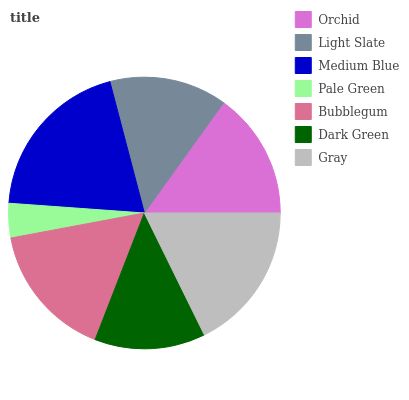Is Pale Green the minimum?
Answer yes or no. Yes. Is Medium Blue the maximum?
Answer yes or no. Yes. Is Light Slate the minimum?
Answer yes or no. No. Is Light Slate the maximum?
Answer yes or no. No. Is Orchid greater than Light Slate?
Answer yes or no. Yes. Is Light Slate less than Orchid?
Answer yes or no. Yes. Is Light Slate greater than Orchid?
Answer yes or no. No. Is Orchid less than Light Slate?
Answer yes or no. No. Is Orchid the high median?
Answer yes or no. Yes. Is Orchid the low median?
Answer yes or no. Yes. Is Light Slate the high median?
Answer yes or no. No. Is Dark Green the low median?
Answer yes or no. No. 